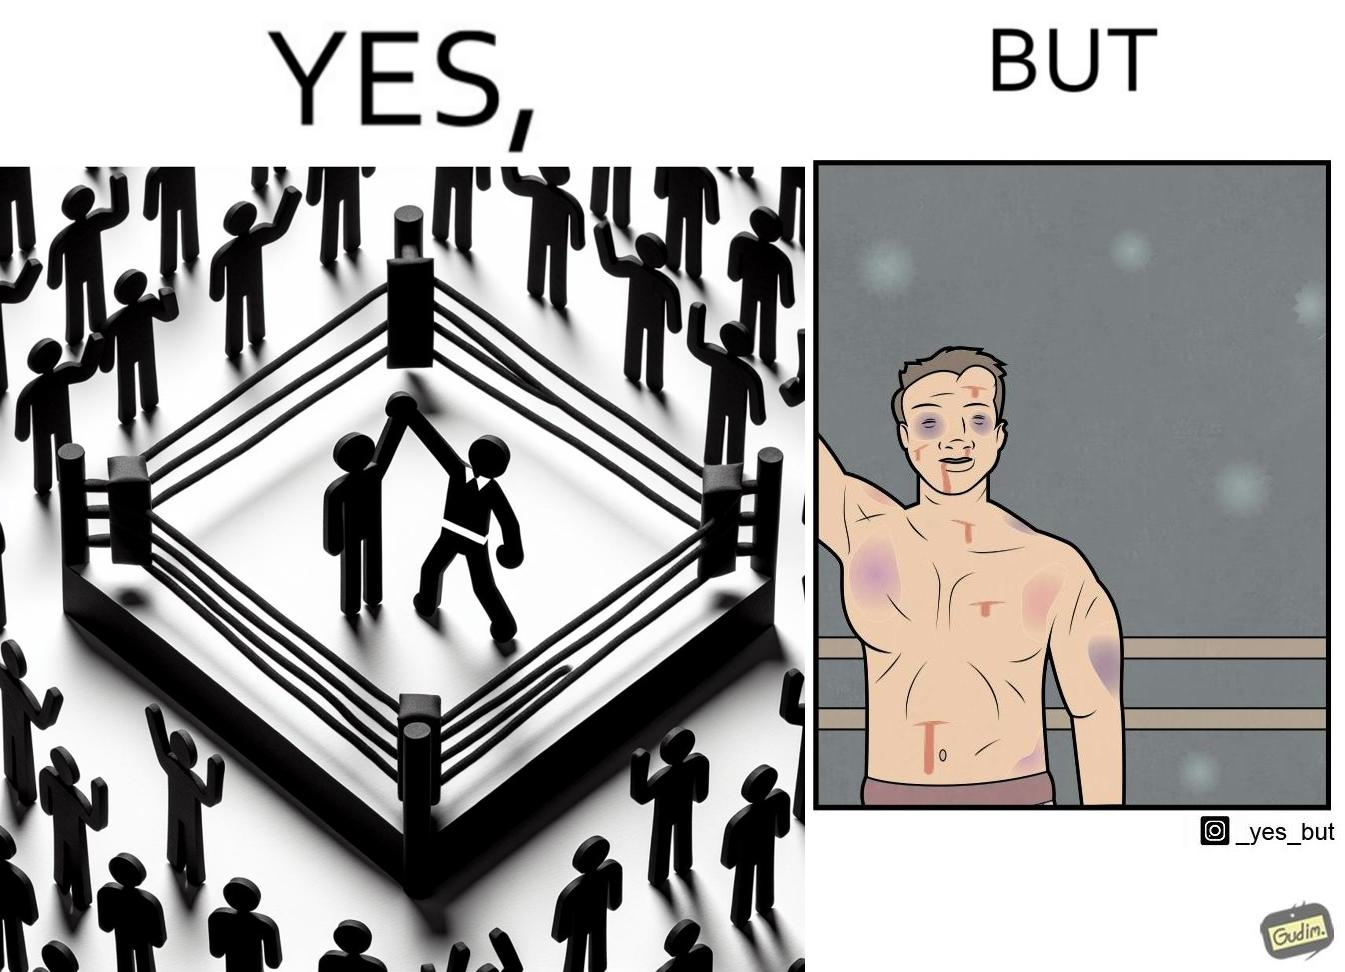Describe the satirical element in this image. The image is ironic because even though a boxer has won the match and it is supposed to be a moment of celebration, the boxer got bruised in several places during the match. This is an illustration of what hurdles a person has to go through in order to succeed. 